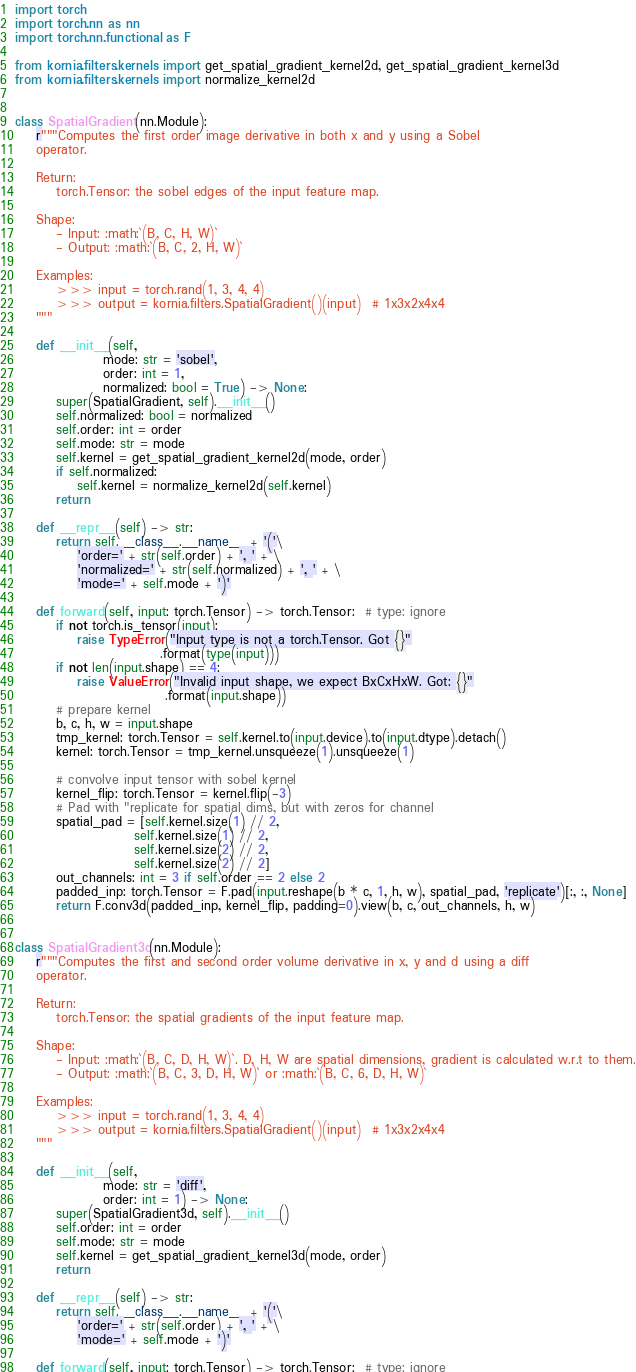<code> <loc_0><loc_0><loc_500><loc_500><_Python_>import torch
import torch.nn as nn
import torch.nn.functional as F

from kornia.filters.kernels import get_spatial_gradient_kernel2d, get_spatial_gradient_kernel3d
from kornia.filters.kernels import normalize_kernel2d


class SpatialGradient(nn.Module):
    r"""Computes the first order image derivative in both x and y using a Sobel
    operator.

    Return:
        torch.Tensor: the sobel edges of the input feature map.

    Shape:
        - Input: :math:`(B, C, H, W)`
        - Output: :math:`(B, C, 2, H, W)`

    Examples:
        >>> input = torch.rand(1, 3, 4, 4)
        >>> output = kornia.filters.SpatialGradient()(input)  # 1x3x2x4x4
    """

    def __init__(self,
                 mode: str = 'sobel',
                 order: int = 1,
                 normalized: bool = True) -> None:
        super(SpatialGradient, self).__init__()
        self.normalized: bool = normalized
        self.order: int = order
        self.mode: str = mode
        self.kernel = get_spatial_gradient_kernel2d(mode, order)
        if self.normalized:
            self.kernel = normalize_kernel2d(self.kernel)
        return

    def __repr__(self) -> str:
        return self.__class__.__name__ + '('\
            'order=' + str(self.order) + ', ' + \
            'normalized=' + str(self.normalized) + ', ' + \
            'mode=' + self.mode + ')'

    def forward(self, input: torch.Tensor) -> torch.Tensor:  # type: ignore
        if not torch.is_tensor(input):
            raise TypeError("Input type is not a torch.Tensor. Got {}"
                            .format(type(input)))
        if not len(input.shape) == 4:
            raise ValueError("Invalid input shape, we expect BxCxHxW. Got: {}"
                             .format(input.shape))
        # prepare kernel
        b, c, h, w = input.shape
        tmp_kernel: torch.Tensor = self.kernel.to(input.device).to(input.dtype).detach()
        kernel: torch.Tensor = tmp_kernel.unsqueeze(1).unsqueeze(1)

        # convolve input tensor with sobel kernel
        kernel_flip: torch.Tensor = kernel.flip(-3)
        # Pad with "replicate for spatial dims, but with zeros for channel
        spatial_pad = [self.kernel.size(1) // 2,
                       self.kernel.size(1) // 2,
                       self.kernel.size(2) // 2,
                       self.kernel.size(2) // 2]
        out_channels: int = 3 if self.order == 2 else 2
        padded_inp: torch.Tensor = F.pad(input.reshape(b * c, 1, h, w), spatial_pad, 'replicate')[:, :, None]
        return F.conv3d(padded_inp, kernel_flip, padding=0).view(b, c, out_channels, h, w)


class SpatialGradient3d(nn.Module):
    r"""Computes the first and second order volume derivative in x, y and d using a diff
    operator.

    Return:
        torch.Tensor: the spatial gradients of the input feature map.

    Shape:
        - Input: :math:`(B, C, D, H, W)`. D, H, W are spatial dimensions, gradient is calculated w.r.t to them.
        - Output: :math:`(B, C, 3, D, H, W)` or :math:`(B, C, 6, D, H, W)`

    Examples:
        >>> input = torch.rand(1, 3, 4, 4)
        >>> output = kornia.filters.SpatialGradient()(input)  # 1x3x2x4x4
    """

    def __init__(self,
                 mode: str = 'diff',
                 order: int = 1) -> None:
        super(SpatialGradient3d, self).__init__()
        self.order: int = order
        self.mode: str = mode
        self.kernel = get_spatial_gradient_kernel3d(mode, order)
        return

    def __repr__(self) -> str:
        return self.__class__.__name__ + '('\
            'order=' + str(self.order) + ', ' + \
            'mode=' + self.mode + ')'

    def forward(self, input: torch.Tensor) -> torch.Tensor:  # type: ignore</code> 